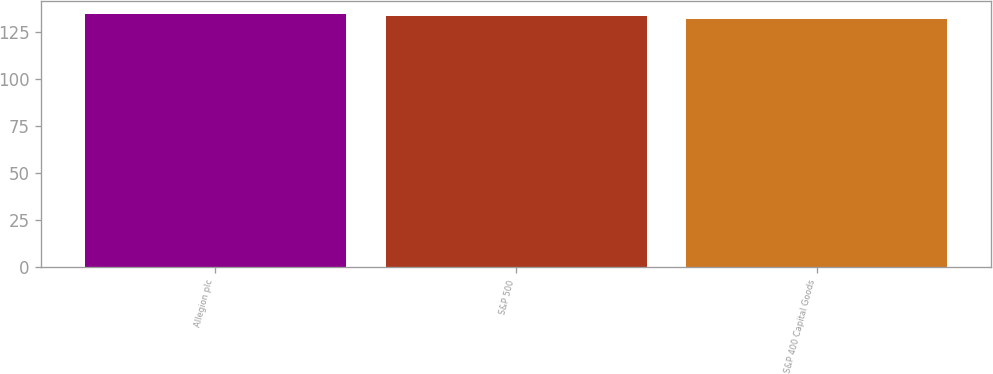<chart> <loc_0><loc_0><loc_500><loc_500><bar_chart><fcel>Allegion plc<fcel>S&P 500<fcel>S&P 400 Capital Goods<nl><fcel>134.67<fcel>133.48<fcel>131.8<nl></chart> 